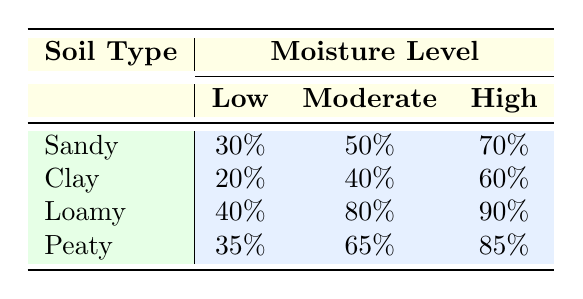What is the success rate of seed germination in Sandy soil at high moisture levels? The table shows that for Sandy soil at high moisture levels, the success rate is 70%.
Answer: 70% Which soil type has the highest success rate at moderate moisture levels? Looking at the table, Loamy soil has the highest success rate at moderate moisture levels with 80%.
Answer: Loamy What is the average success rate of seed germination across all soil types at low moisture levels? To find the average, we add the success rates for each soil type at low moisture levels: 30 + 20 + 40 + 35 = 125. Then we divide by 4 (the number of soil types), giving us an average of 31.25.
Answer: 31.25 Is the success rate of seed germination in Peaty soil at high moisture levels higher than in Sandy soil at the same moisture level? The success rate in Peaty soil at high moisture levels is 85%, while in Sandy soil it is 70%. Thus, 85% is greater than 70%.
Answer: Yes How much higher is the success rate of seed germination in Loamy soil at high moisture levels compared to Clay soil at the same moisture level? The success rate for Loamy soil at high moisture levels is 90%, while for Clay soil it is 60%. To find the difference, we subtract: 90 - 60 = 30.
Answer: 30 What is the success rate of seed germination in Clay soil at low moisture levels? Is it a success rate below 25%? The table indicates that the success rate for Clay soil at low moisture levels is 20%. Since 20% is below 25%, the answer is yes.
Answer: Yes Which soil type shows the least improvement in seed germination success rate from low to high moisture levels? Observing the success rate changes from low to high moisture for each soil type: Sandy (30% to 70% = 40%), Clay (20% to 60% = 40%), Loamy (40% to 90% = 50%), and Peaty (35% to 85% = 50%). Sandy and Clay show the least improvement of 40%.
Answer: Sandy and Clay What is the total percentage of success rates for all soil types under moderate moisture levels? To calculate the total success rates under moderate conditions, we add: 50 (Sandy) + 40 (Clay) + 80 (Loamy) + 65 (Peaty) = 235.
Answer: 235 Which soil type has the least success rate overall regardless of moisture levels? Reviewing the table's success rates for each soil type yields: Sandy (30, 50, 70), Clay (20, 40, 60), Loamy (40, 80, 90), and Peaty (35, 65, 85). The lowest value appears to be 20% in Clay soil.
Answer: Clay 